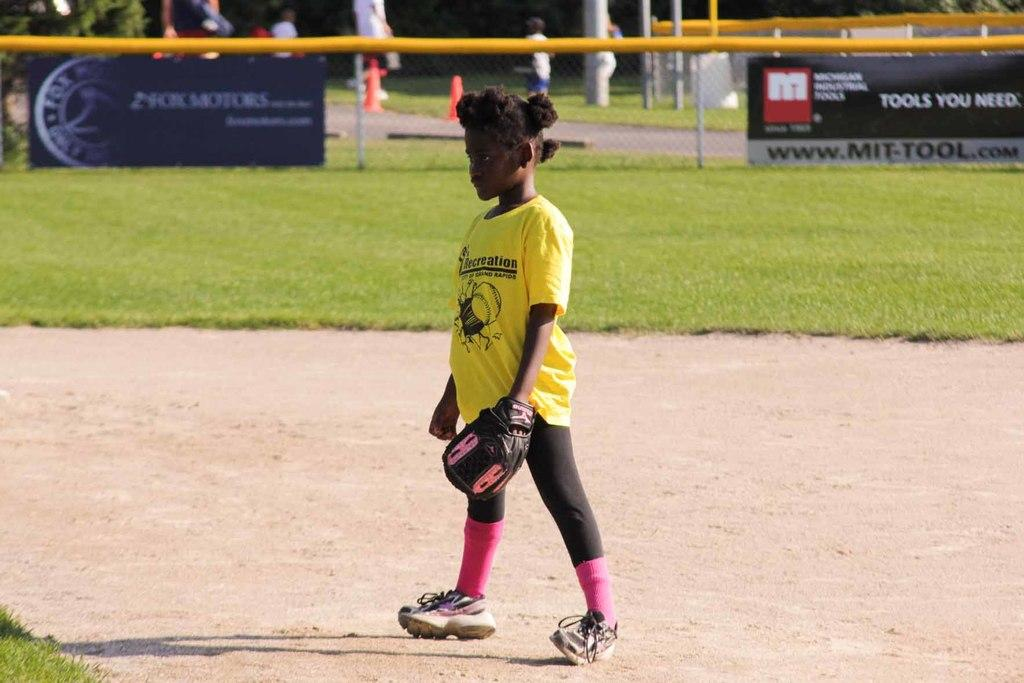Provide a one-sentence caption for the provided image. a little girl on a baseball field with a shirt that says 'recreation' on it. 